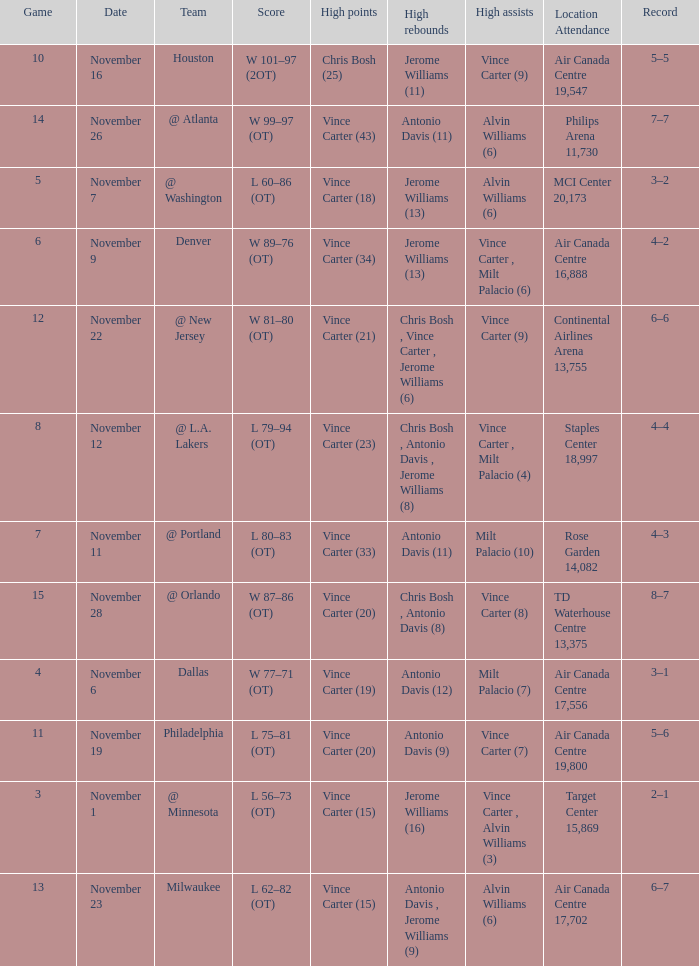On what date was the attendance at Continental Airlines Arena 13,755? November 22. 